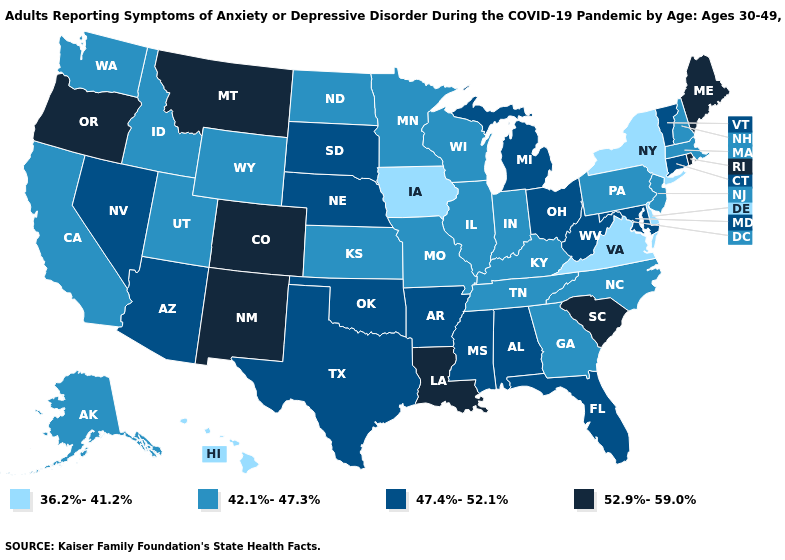Name the states that have a value in the range 42.1%-47.3%?
Give a very brief answer. Alaska, California, Georgia, Idaho, Illinois, Indiana, Kansas, Kentucky, Massachusetts, Minnesota, Missouri, New Hampshire, New Jersey, North Carolina, North Dakota, Pennsylvania, Tennessee, Utah, Washington, Wisconsin, Wyoming. Among the states that border Vermont , does New Hampshire have the highest value?
Concise answer only. Yes. What is the value of Michigan?
Concise answer only. 47.4%-52.1%. Among the states that border Mississippi , does Arkansas have the lowest value?
Give a very brief answer. No. What is the highest value in the Northeast ?
Quick response, please. 52.9%-59.0%. What is the value of New Mexico?
Keep it brief. 52.9%-59.0%. Name the states that have a value in the range 47.4%-52.1%?
Concise answer only. Alabama, Arizona, Arkansas, Connecticut, Florida, Maryland, Michigan, Mississippi, Nebraska, Nevada, Ohio, Oklahoma, South Dakota, Texas, Vermont, West Virginia. What is the value of Colorado?
Short answer required. 52.9%-59.0%. Among the states that border Wyoming , which have the lowest value?
Quick response, please. Idaho, Utah. How many symbols are there in the legend?
Concise answer only. 4. Which states have the lowest value in the USA?
Give a very brief answer. Delaware, Hawaii, Iowa, New York, Virginia. Name the states that have a value in the range 52.9%-59.0%?
Quick response, please. Colorado, Louisiana, Maine, Montana, New Mexico, Oregon, Rhode Island, South Carolina. What is the value of California?
Quick response, please. 42.1%-47.3%. What is the value of Nebraska?
Answer briefly. 47.4%-52.1%. Does Virginia have the lowest value in the South?
Give a very brief answer. Yes. 